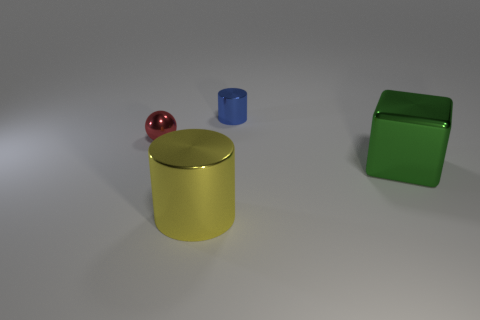Add 4 small blue metal objects. How many objects exist? 8 Subtract all spheres. How many objects are left? 3 Add 3 green blocks. How many green blocks are left? 4 Add 2 small yellow balls. How many small yellow balls exist? 2 Subtract 0 green cylinders. How many objects are left? 4 Subtract all small cylinders. Subtract all gray things. How many objects are left? 3 